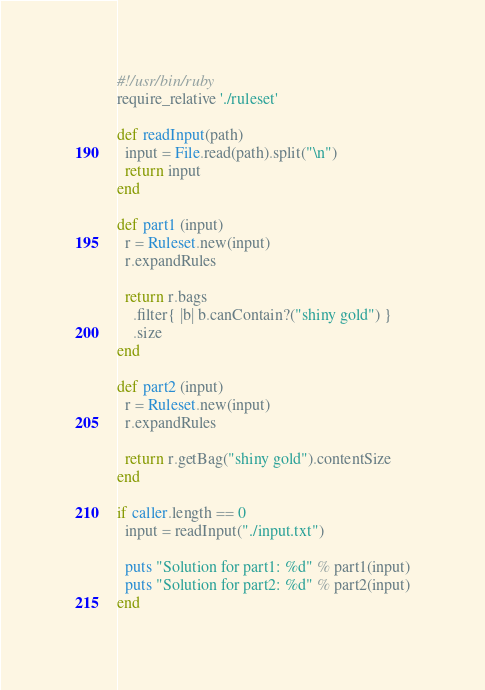<code> <loc_0><loc_0><loc_500><loc_500><_Ruby_>#!/usr/bin/ruby
require_relative './ruleset'

def readInput(path)
  input = File.read(path).split("\n")
  return input
end

def part1 (input)
  r = Ruleset.new(input)
  r.expandRules

  return r.bags
    .filter{ |b| b.canContain?("shiny gold") }
    .size
end

def part2 (input)
  r = Ruleset.new(input)
  r.expandRules

  return r.getBag("shiny gold").contentSize
end

if caller.length == 0
  input = readInput("./input.txt")

  puts "Solution for part1: %d" % part1(input)
  puts "Solution for part2: %d" % part2(input)
end</code> 